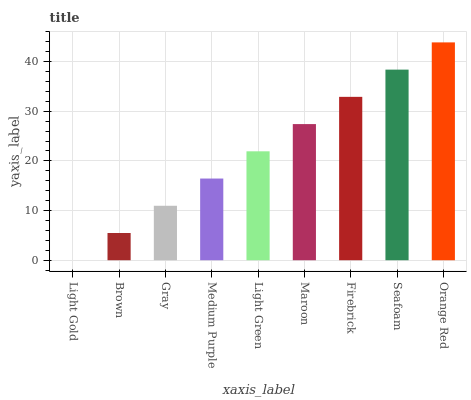Is Light Gold the minimum?
Answer yes or no. Yes. Is Orange Red the maximum?
Answer yes or no. Yes. Is Brown the minimum?
Answer yes or no. No. Is Brown the maximum?
Answer yes or no. No. Is Brown greater than Light Gold?
Answer yes or no. Yes. Is Light Gold less than Brown?
Answer yes or no. Yes. Is Light Gold greater than Brown?
Answer yes or no. No. Is Brown less than Light Gold?
Answer yes or no. No. Is Light Green the high median?
Answer yes or no. Yes. Is Light Green the low median?
Answer yes or no. Yes. Is Maroon the high median?
Answer yes or no. No. Is Gray the low median?
Answer yes or no. No. 